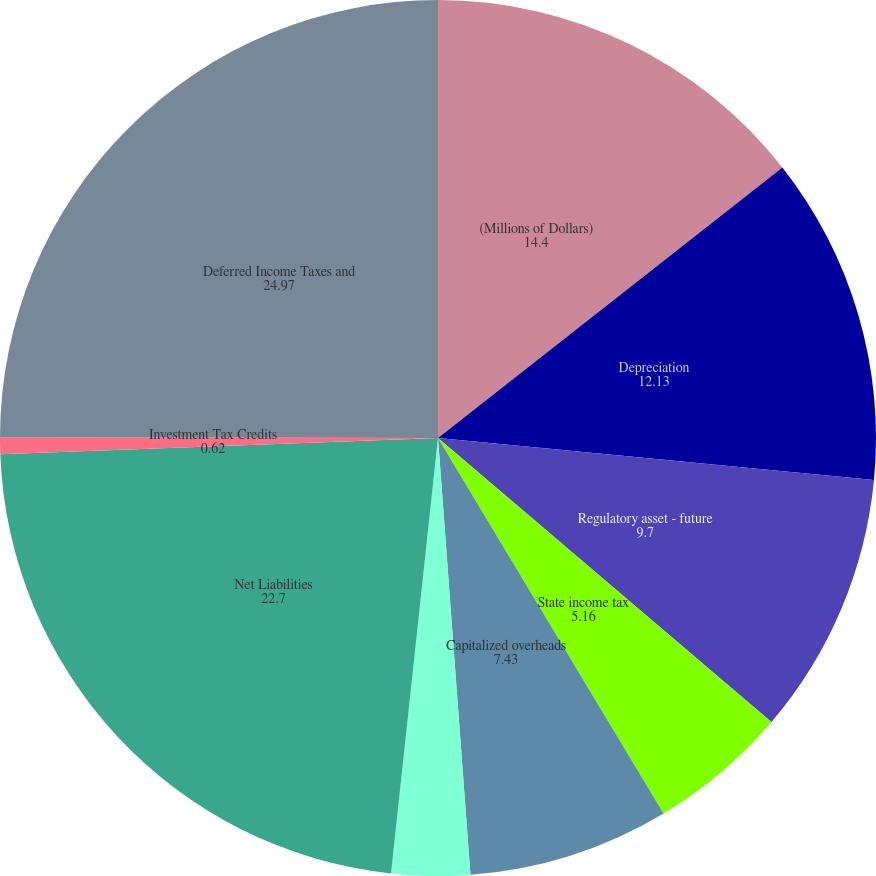<chart> <loc_0><loc_0><loc_500><loc_500><pie_chart><fcel>(Millions of Dollars)<fcel>Depreciation<fcel>Regulatory asset - future<fcel>State income tax<fcel>Capitalized overheads<fcel>Other<fcel>Net Liabilities<fcel>Investment Tax Credits<fcel>Deferred Income Taxes and<nl><fcel>14.4%<fcel>12.13%<fcel>9.7%<fcel>5.16%<fcel>7.43%<fcel>2.89%<fcel>22.7%<fcel>0.62%<fcel>24.97%<nl></chart> 